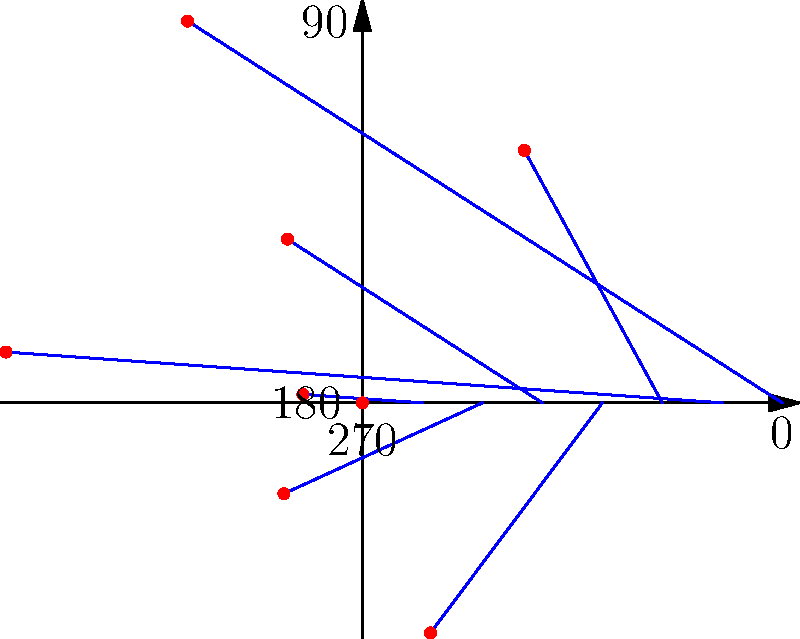A city activist group has mapped the distribution of legal advertisement billboards around the city center using polar coordinates. The angular spread is shown in the diagram, where the distance from the center represents the number of billboards in that direction. What is the total number of billboards in the directions between $135°$ and $315°$ (counterclockwise)? To solve this problem, we need to sum the number of billboards in the directions between $135°$ and $315°$ (counterclockwise). Let's break it down step-by-step:

1. Identify the relevant directions:
   - $135°$
   - $180°$
   - $225°$
   - $270°$
   - $315°$

2. Count the number of billboards in each direction:
   - At $135°$: 2 billboards
   - At $180°$: 5 billboards
   - At $225°$: 1 billboard
   - At $270°$: 3 billboards
   - At $315°$: 2 billboards

3. Sum up the total number of billboards:
   $2 + 5 + 1 + 3 + 2 = 13$

Therefore, the total number of billboards in the directions between $135°$ and $315°$ (counterclockwise) is 13.
Answer: 13 billboards 